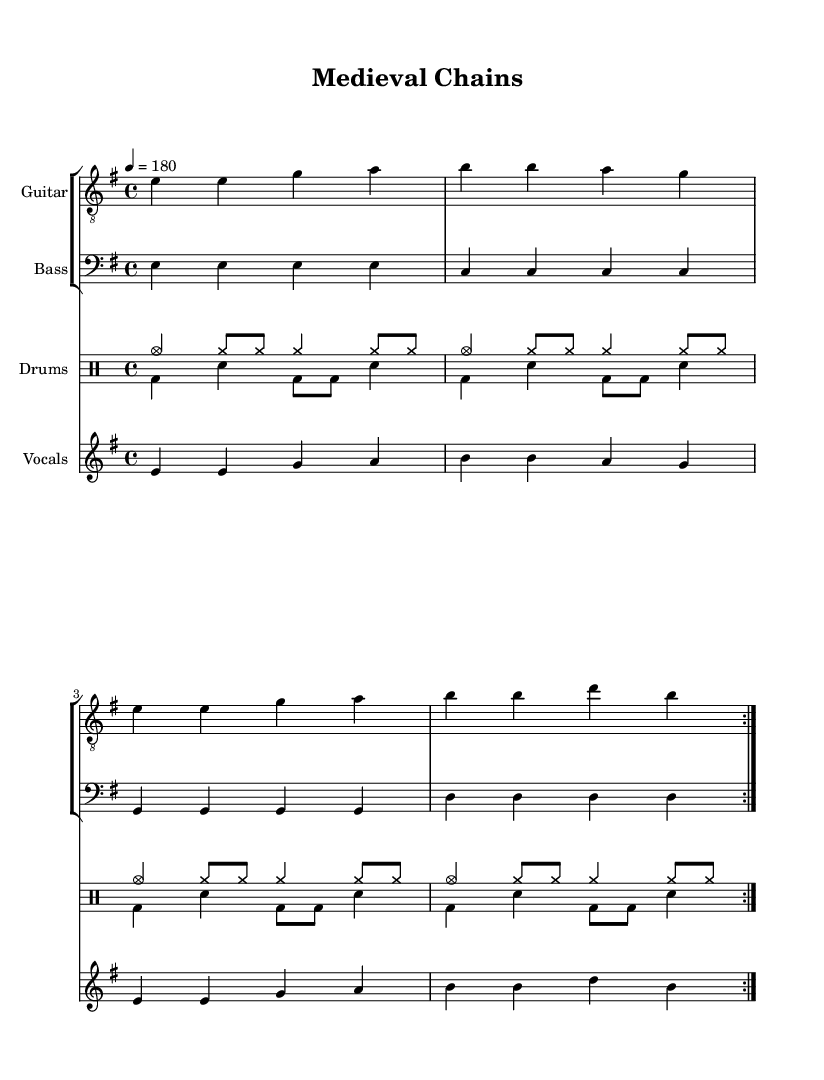What is the key signature of this music? The key signature is E minor, which is indicated by one sharp (F#).
Answer: E minor What is the time signature of this piece? The time signature is 4/4, meaning there are four beats in each measure.
Answer: 4/4 What is the tempo marking for this song? The tempo marking indicates a speed of 180 beats per minute.
Answer: 180 How many times is the main guitar section repeated? The main guitar section is repeated two times, as indicated by the volta markings.
Answer: 2 What is the primary theme of the lyrics based on the title? The lyrics describe a theme of constraint and historical influence, hinting at the Church's impact during the Middle Ages.
Answer: Constraint What instruments make up this composition? The composition includes guitar, bass, drums, and vocals, which are clearly defined in separate staves.
Answer: Guitar, bass, drums, vocals Which musical genre does this song embody? This song embodies the punk genre, characterized by its fast tempo and critical lyrics often aimed at societal issues, including religious institutions.
Answer: Punk 